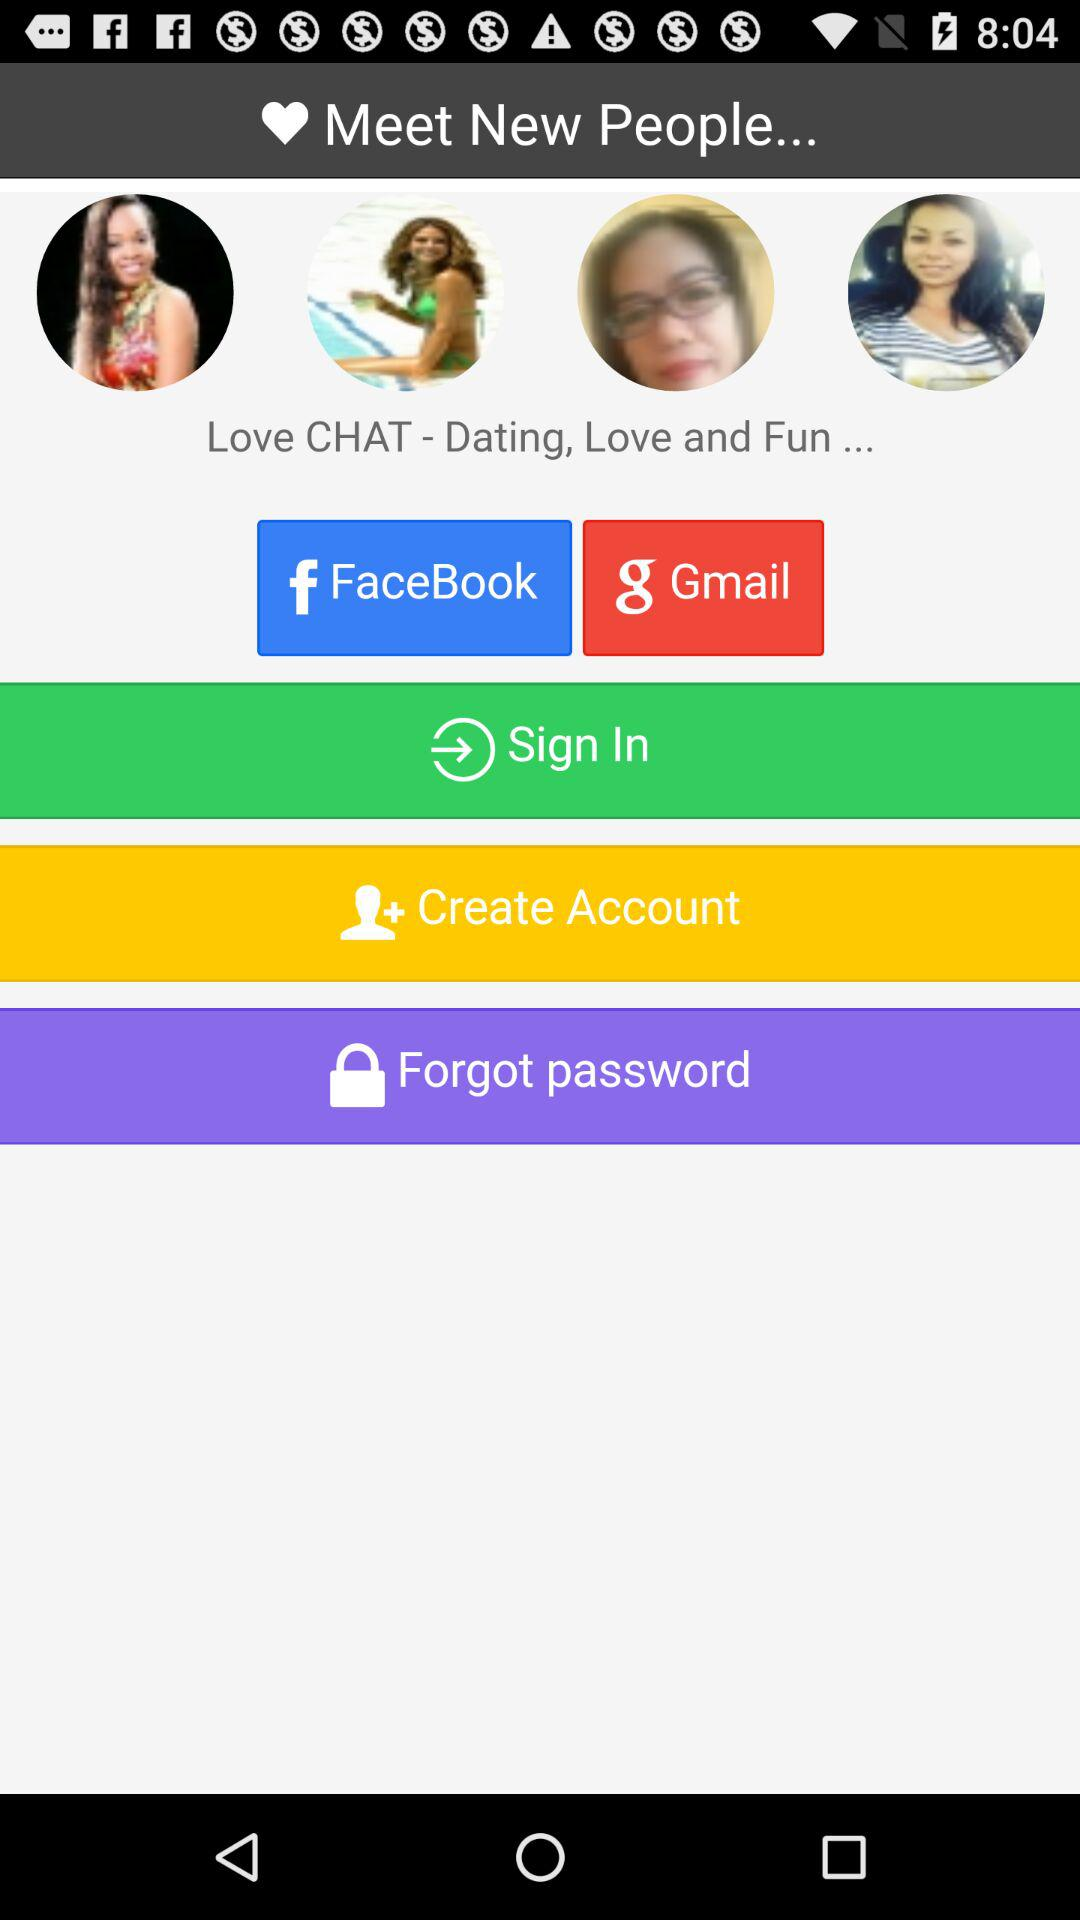How many people like this application?
When the provided information is insufficient, respond with <no answer>. <no answer> 